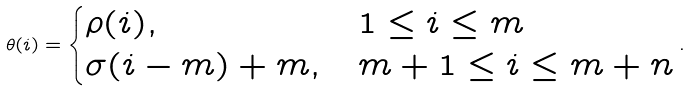<formula> <loc_0><loc_0><loc_500><loc_500>\theta ( i ) = \begin{cases} \rho ( i ) , & 1 \leq i \leq m \\ \sigma ( i - m ) + m , & m + 1 \leq i \leq m + n \end{cases} .</formula> 